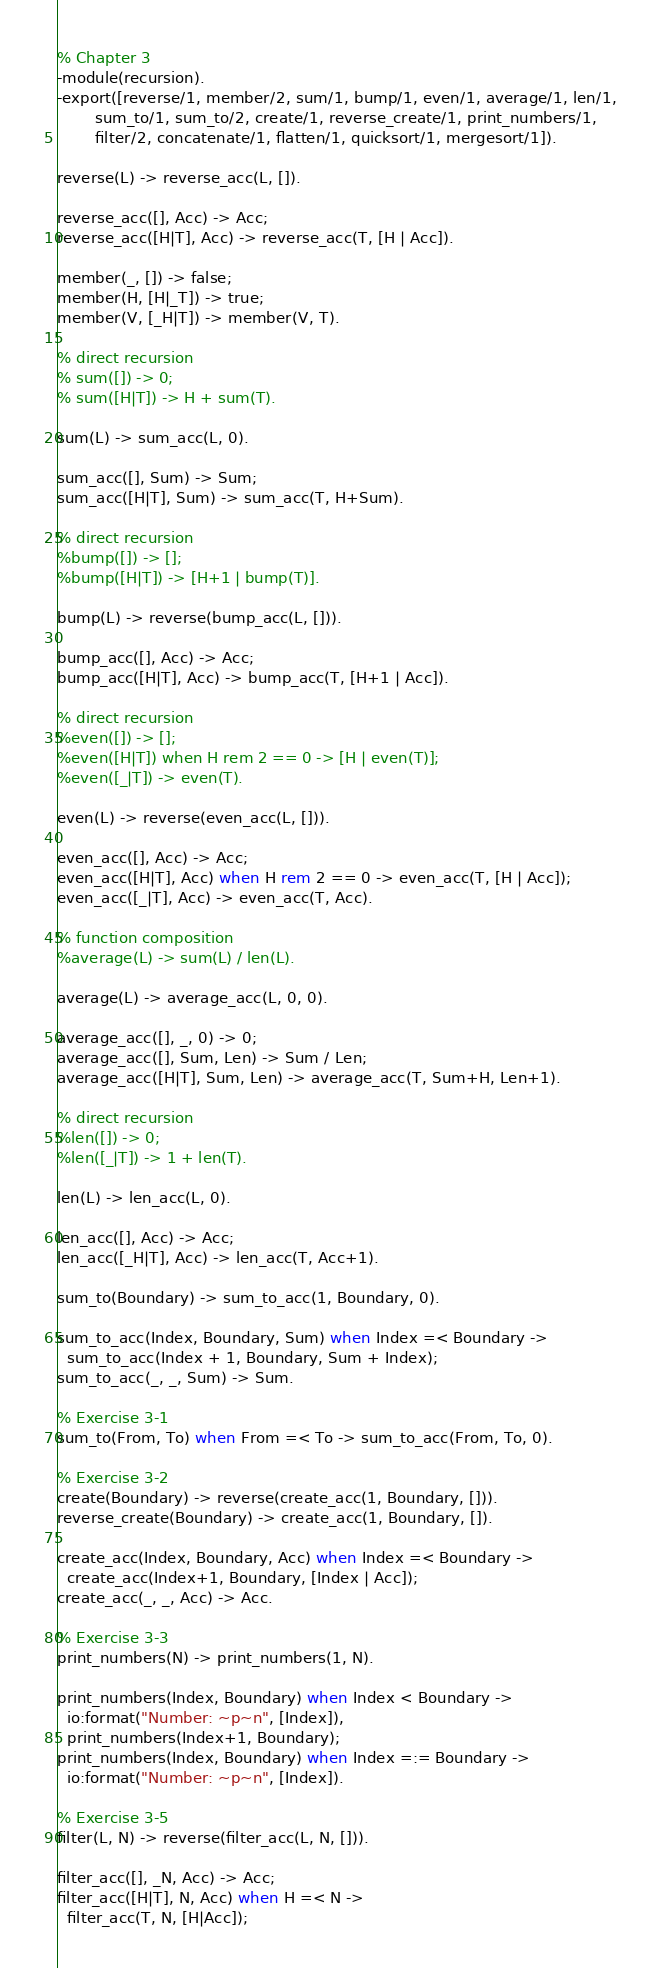Convert code to text. <code><loc_0><loc_0><loc_500><loc_500><_Erlang_>% Chapter 3
-module(recursion).
-export([reverse/1, member/2, sum/1, bump/1, even/1, average/1, len/1,
        sum_to/1, sum_to/2, create/1, reverse_create/1, print_numbers/1,
        filter/2, concatenate/1, flatten/1, quicksort/1, mergesort/1]).

reverse(L) -> reverse_acc(L, []).

reverse_acc([], Acc) -> Acc;
reverse_acc([H|T], Acc) -> reverse_acc(T, [H | Acc]).

member(_, []) -> false;
member(H, [H|_T]) -> true;
member(V, [_H|T]) -> member(V, T).

% direct recursion
% sum([]) -> 0;
% sum([H|T]) -> H + sum(T).

sum(L) -> sum_acc(L, 0).

sum_acc([], Sum) -> Sum;
sum_acc([H|T], Sum) -> sum_acc(T, H+Sum).

% direct recursion
%bump([]) -> [];
%bump([H|T]) -> [H+1 | bump(T)].

bump(L) -> reverse(bump_acc(L, [])).

bump_acc([], Acc) -> Acc;
bump_acc([H|T], Acc) -> bump_acc(T, [H+1 | Acc]).

% direct recursion
%even([]) -> [];
%even([H|T]) when H rem 2 == 0 -> [H | even(T)];
%even([_|T]) -> even(T).

even(L) -> reverse(even_acc(L, [])).

even_acc([], Acc) -> Acc;
even_acc([H|T], Acc) when H rem 2 == 0 -> even_acc(T, [H | Acc]);
even_acc([_|T], Acc) -> even_acc(T, Acc).

% function composition
%average(L) -> sum(L) / len(L).

average(L) -> average_acc(L, 0, 0).

average_acc([], _, 0) -> 0;
average_acc([], Sum, Len) -> Sum / Len;
average_acc([H|T], Sum, Len) -> average_acc(T, Sum+H, Len+1).

% direct recursion
%len([]) -> 0;
%len([_|T]) -> 1 + len(T).

len(L) -> len_acc(L, 0).

len_acc([], Acc) -> Acc;
len_acc([_H|T], Acc) -> len_acc(T, Acc+1).

sum_to(Boundary) -> sum_to_acc(1, Boundary, 0).

sum_to_acc(Index, Boundary, Sum) when Index =< Boundary ->
  sum_to_acc(Index + 1, Boundary, Sum + Index);
sum_to_acc(_, _, Sum) -> Sum.

% Exercise 3-1
sum_to(From, To) when From =< To -> sum_to_acc(From, To, 0).

% Exercise 3-2
create(Boundary) -> reverse(create_acc(1, Boundary, [])).
reverse_create(Boundary) -> create_acc(1, Boundary, []).

create_acc(Index, Boundary, Acc) when Index =< Boundary ->
  create_acc(Index+1, Boundary, [Index | Acc]);
create_acc(_, _, Acc) -> Acc.

% Exercise 3-3
print_numbers(N) -> print_numbers(1, N).

print_numbers(Index, Boundary) when Index < Boundary ->
  io:format("Number: ~p~n", [Index]),
  print_numbers(Index+1, Boundary);
print_numbers(Index, Boundary) when Index =:= Boundary ->
  io:format("Number: ~p~n", [Index]).

% Exercise 3-5
filter(L, N) -> reverse(filter_acc(L, N, [])).

filter_acc([], _N, Acc) -> Acc;
filter_acc([H|T], N, Acc) when H =< N ->
  filter_acc(T, N, [H|Acc]);</code> 